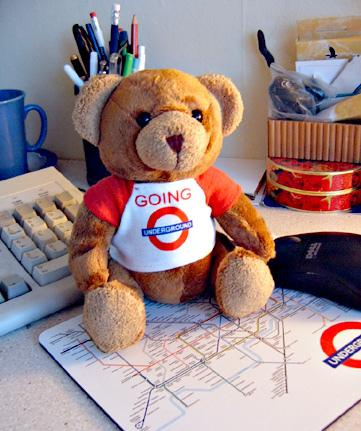What color is the big circular ring in the logo of the bear's t-shirt?

Choices:
A) blue
B) yellow
C) red
D) pink red 